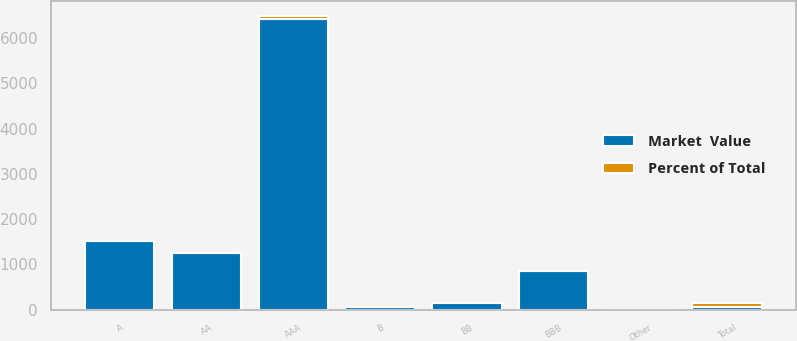<chart> <loc_0><loc_0><loc_500><loc_500><stacked_bar_chart><ecel><fcel>AAA<fcel>AA<fcel>A<fcel>BBB<fcel>BB<fcel>B<fcel>Other<fcel>Total<nl><fcel>Market  Value<fcel>6422<fcel>1250.5<fcel>1510.3<fcel>847.2<fcel>152.8<fcel>58.2<fcel>4.6<fcel>58.2<nl><fcel>Percent of Total<fcel>62.7<fcel>12.2<fcel>14.7<fcel>8.3<fcel>1.5<fcel>0.6<fcel>0<fcel>100<nl></chart> 